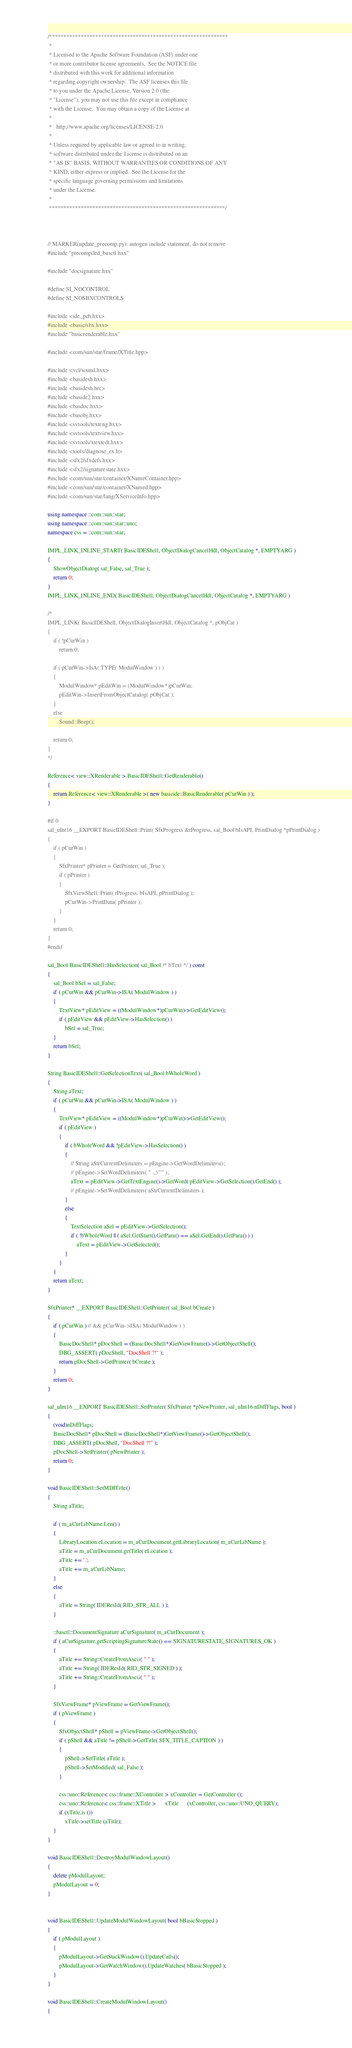<code> <loc_0><loc_0><loc_500><loc_500><_C++_>/**************************************************************
 * 
 * Licensed to the Apache Software Foundation (ASF) under one
 * or more contributor license agreements.  See the NOTICE file
 * distributed with this work for additional information
 * regarding copyright ownership.  The ASF licenses this file
 * to you under the Apache License, Version 2.0 (the
 * "License"); you may not use this file except in compliance
 * with the License.  You may obtain a copy of the License at
 * 
 *   http://www.apache.org/licenses/LICENSE-2.0
 * 
 * Unless required by applicable law or agreed to in writing,
 * software distributed under the License is distributed on an
 * "AS IS" BASIS, WITHOUT WARRANTIES OR CONDITIONS OF ANY
 * KIND, either express or implied.  See the License for the
 * specific language governing permissions and limitations
 * under the License.
 * 
 *************************************************************/



// MARKER(update_precomp.py): autogen include statement, do not remove
#include "precompiled_basctl.hxx"

#include "docsignature.hxx"

#define SI_NOCONTROL
#define SI_NOSBXCONTROLS

#include <ide_pch.hxx>
#include <basic/sbx.hxx>
#include "basicrenderable.hxx"

#include <com/sun/star/frame/XTitle.hpp>

#include <vcl/sound.hxx>
#include <basidesh.hxx>
#include <basidesh.hrc>
#include <baside2.hxx>
#include <basdoc.hxx>
#include <basobj.hxx>
#include <svtools/texteng.hxx>
#include <svtools/textview.hxx>
#include <svtools/xtextedt.hxx>
#include <tools/diagnose_ex.h>
#include <sfx2/sfxdefs.hxx>
#include <sfx2/signaturestate.hxx>
#include <com/sun/star/container/XNameContainer.hpp>
#include <com/sun/star/container/XNamed.hpp>
#include <com/sun/star/lang/XServiceInfo.hpp>

using namespace ::com::sun::star;
using namespace ::com::sun::star::uno;
namespace css = ::com::sun::star;

IMPL_LINK_INLINE_START( BasicIDEShell, ObjectDialogCancelHdl, ObjectCatalog *, EMPTYARG )
{
	ShowObjectDialog( sal_False, sal_True );
	return 0;
}
IMPL_LINK_INLINE_END( BasicIDEShell, ObjectDialogCancelHdl, ObjectCatalog *, EMPTYARG )

/*
IMPL_LINK( BasicIDEShell, ObjectDialogInsertHdl, ObjectCatalog *, pObjCat )
{
	if ( !pCurWin )
		return 0;

	if ( pCurWin->IsA( TYPE( ModulWindow ) ) )
	{
		ModulWindow* pEditWin = (ModulWindow*)pCurWin;
		pEditWin->InsertFromObjectCatalog( pObjCat );
	}
	else
		Sound::Beep();

	return 0;
}
*/

Reference< view::XRenderable > BasicIDEShell::GetRenderable()
{
    return Reference< view::XRenderable >( new basicide::BasicRenderable( pCurWin ) );
}

#if 0
sal_uInt16 __EXPORT BasicIDEShell::Print( SfxProgress &rProgress, sal_Bool bIsAPI, PrintDialog *pPrintDialog )
{
	if ( pCurWin )
	{
		SfxPrinter* pPrinter = GetPrinter( sal_True );
		if ( pPrinter )
		{
			SfxViewShell::Print( rProgress, bIsAPI, pPrintDialog );
			pCurWin->PrintData( pPrinter );
		}
	}
	return 0;
}
#endif

sal_Bool BasicIDEShell::HasSelection( sal_Bool /* bText */ ) const
{
	sal_Bool bSel = sal_False;
	if ( pCurWin && pCurWin->ISA( ModulWindow ) )
	{
		TextView* pEditView = ((ModulWindow*)pCurWin)->GetEditView();
		if ( pEditView && pEditView->HasSelection() )
			bSel = sal_True;
	}
	return bSel;
}

String BasicIDEShell::GetSelectionText( sal_Bool bWholeWord )
{
	String aText;
	if ( pCurWin && pCurWin->ISA( ModulWindow ) )
	{
		TextView* pEditView = ((ModulWindow*)pCurWin)->GetEditView();
		if ( pEditView )
		{
			if ( bWholeWord && !pEditView->HasSelection() )
			{
				// String aStrCurrentDelimiters = pEngine->GetWordDelimiters();
				// pEngine->SetWordDelimiters( " .,;\"'" );
				aText = pEditView->GetTextEngine()->GetWord( pEditView->GetSelection().GetEnd() );
				// pEngine->SetWordDelimiters( aStrCurrentDelimiters );
			}
			else
			{
				TextSelection aSel = pEditView->GetSelection();
				if ( !bWholeWord || ( aSel.GetStart().GetPara() == aSel.GetEnd().GetPara() ) )
					aText = pEditView->GetSelected();
			}
		}
	}
	return aText;
}

SfxPrinter* __EXPORT BasicIDEShell::GetPrinter( sal_Bool bCreate )
{
	if ( pCurWin ) // && pCurWin->ISA( ModulWindow ) )
	{
		BasicDocShell* pDocShell = (BasicDocShell*)GetViewFrame()->GetObjectShell();
		DBG_ASSERT( pDocShell, "DocShell ?!" );
		return pDocShell->GetPrinter( bCreate );
	}
	return 0;
}

sal_uInt16 __EXPORT BasicIDEShell::SetPrinter( SfxPrinter *pNewPrinter, sal_uInt16 nDiffFlags, bool )
{
	(void)nDiffFlags;
	BasicDocShell* pDocShell = (BasicDocShell*)GetViewFrame()->GetObjectShell();
	DBG_ASSERT( pDocShell, "DocShell ?!" );
	pDocShell->SetPrinter( pNewPrinter );
	return 0;
}

void BasicIDEShell::SetMDITitle()
{
	String aTitle;

    if ( m_aCurLibName.Len() )
    {
        LibraryLocation eLocation = m_aCurDocument.getLibraryLocation( m_aCurLibName );
        aTitle = m_aCurDocument.getTitle( eLocation );
        aTitle += '.';
        aTitle += m_aCurLibName;
	}
    else
    {
        aTitle = String( IDEResId( RID_STR_ALL ) );
    }

    ::basctl::DocumentSignature aCurSignature( m_aCurDocument );
    if ( aCurSignature.getScriptingSignatureState() == SIGNATURESTATE_SIGNATURES_OK )
    {
        aTitle += String::CreateFromAscii( " " );
        aTitle += String( IDEResId( RID_STR_SIGNED ) );
        aTitle += String::CreateFromAscii( " " );
    }

    SfxViewFrame* pViewFrame = GetViewFrame();
    if ( pViewFrame )
    {
        SfxObjectShell* pShell = pViewFrame->GetObjectShell();
        if ( pShell && aTitle != pShell->GetTitle( SFX_TITLE_CAPTION ) )
        {
            pShell->SetTitle( aTitle );
            pShell->SetModified( sal_False );
        }
    
        css::uno::Reference< css::frame::XController > xController = GetController ();
        css::uno::Reference< css::frame::XTitle >      xTitle      (xController, css::uno::UNO_QUERY);
        if (xTitle.is ())
            xTitle->setTitle (aTitle);
    }
}

void BasicIDEShell::DestroyModulWindowLayout()
{
	delete pModulLayout;
	pModulLayout = 0;
}


void BasicIDEShell::UpdateModulWindowLayout( bool bBasicStopped )
{
	if ( pModulLayout )
	{
		pModulLayout->GetStackWindow().UpdateCalls();
		pModulLayout->GetWatchWindow().UpdateWatches( bBasicStopped );
	}
}

void BasicIDEShell::CreateModulWindowLayout()
{</code> 